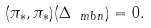<formula> <loc_0><loc_0><loc_500><loc_500>( \pi _ { * } , \pi _ { * } ) ( \Delta _ { \ m b n } ) = 0 .</formula> 